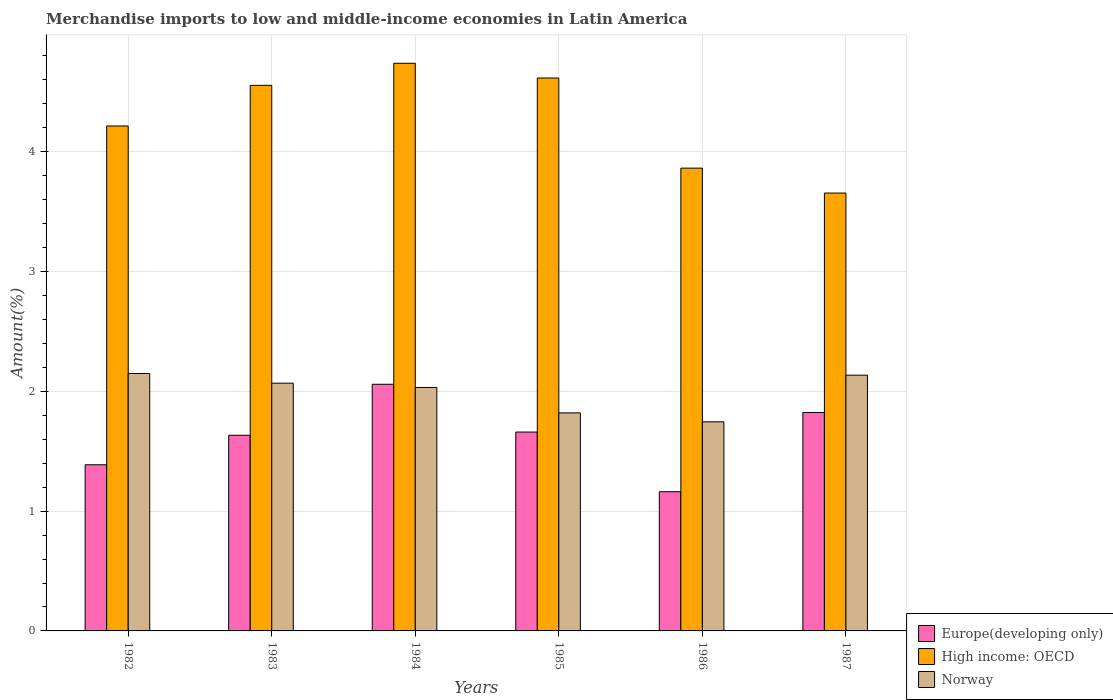How many different coloured bars are there?
Keep it short and to the point. 3. Are the number of bars per tick equal to the number of legend labels?
Offer a terse response. Yes. How many bars are there on the 6th tick from the left?
Give a very brief answer. 3. How many bars are there on the 1st tick from the right?
Your answer should be compact. 3. What is the percentage of amount earned from merchandise imports in High income: OECD in 1984?
Offer a terse response. 4.74. Across all years, what is the maximum percentage of amount earned from merchandise imports in Europe(developing only)?
Offer a terse response. 2.06. Across all years, what is the minimum percentage of amount earned from merchandise imports in High income: OECD?
Give a very brief answer. 3.66. In which year was the percentage of amount earned from merchandise imports in Europe(developing only) maximum?
Ensure brevity in your answer.  1984. In which year was the percentage of amount earned from merchandise imports in Norway minimum?
Provide a short and direct response. 1986. What is the total percentage of amount earned from merchandise imports in High income: OECD in the graph?
Offer a very short reply. 25.64. What is the difference between the percentage of amount earned from merchandise imports in Norway in 1984 and that in 1987?
Ensure brevity in your answer.  -0.1. What is the difference between the percentage of amount earned from merchandise imports in High income: OECD in 1987 and the percentage of amount earned from merchandise imports in Europe(developing only) in 1983?
Offer a very short reply. 2.02. What is the average percentage of amount earned from merchandise imports in Europe(developing only) per year?
Your answer should be very brief. 1.62. In the year 1987, what is the difference between the percentage of amount earned from merchandise imports in Norway and percentage of amount earned from merchandise imports in High income: OECD?
Provide a short and direct response. -1.52. In how many years, is the percentage of amount earned from merchandise imports in Norway greater than 2 %?
Provide a succinct answer. 4. What is the ratio of the percentage of amount earned from merchandise imports in Europe(developing only) in 1983 to that in 1986?
Provide a short and direct response. 1.41. Is the percentage of amount earned from merchandise imports in High income: OECD in 1982 less than that in 1983?
Your response must be concise. Yes. Is the difference between the percentage of amount earned from merchandise imports in Norway in 1982 and 1986 greater than the difference between the percentage of amount earned from merchandise imports in High income: OECD in 1982 and 1986?
Your answer should be compact. Yes. What is the difference between the highest and the second highest percentage of amount earned from merchandise imports in Europe(developing only)?
Provide a short and direct response. 0.24. What is the difference between the highest and the lowest percentage of amount earned from merchandise imports in Europe(developing only)?
Your response must be concise. 0.9. Is the sum of the percentage of amount earned from merchandise imports in Norway in 1982 and 1983 greater than the maximum percentage of amount earned from merchandise imports in Europe(developing only) across all years?
Provide a short and direct response. Yes. What does the 1st bar from the left in 1987 represents?
Your answer should be very brief. Europe(developing only). What does the 3rd bar from the right in 1987 represents?
Give a very brief answer. Europe(developing only). Is it the case that in every year, the sum of the percentage of amount earned from merchandise imports in High income: OECD and percentage of amount earned from merchandise imports in Europe(developing only) is greater than the percentage of amount earned from merchandise imports in Norway?
Your answer should be compact. Yes. How many bars are there?
Your answer should be very brief. 18. How many years are there in the graph?
Your answer should be very brief. 6. What is the difference between two consecutive major ticks on the Y-axis?
Offer a terse response. 1. Does the graph contain grids?
Offer a very short reply. Yes. How many legend labels are there?
Give a very brief answer. 3. How are the legend labels stacked?
Keep it short and to the point. Vertical. What is the title of the graph?
Your response must be concise. Merchandise imports to low and middle-income economies in Latin America. Does "Faeroe Islands" appear as one of the legend labels in the graph?
Your answer should be compact. No. What is the label or title of the X-axis?
Give a very brief answer. Years. What is the label or title of the Y-axis?
Ensure brevity in your answer.  Amount(%). What is the Amount(%) in Europe(developing only) in 1982?
Provide a succinct answer. 1.39. What is the Amount(%) in High income: OECD in 1982?
Offer a terse response. 4.21. What is the Amount(%) in Norway in 1982?
Keep it short and to the point. 2.15. What is the Amount(%) of Europe(developing only) in 1983?
Your answer should be very brief. 1.63. What is the Amount(%) of High income: OECD in 1983?
Your response must be concise. 4.55. What is the Amount(%) of Norway in 1983?
Give a very brief answer. 2.07. What is the Amount(%) in Europe(developing only) in 1984?
Your answer should be very brief. 2.06. What is the Amount(%) in High income: OECD in 1984?
Offer a terse response. 4.74. What is the Amount(%) of Norway in 1984?
Make the answer very short. 2.03. What is the Amount(%) in Europe(developing only) in 1985?
Your response must be concise. 1.66. What is the Amount(%) in High income: OECD in 1985?
Ensure brevity in your answer.  4.62. What is the Amount(%) of Norway in 1985?
Ensure brevity in your answer.  1.82. What is the Amount(%) in Europe(developing only) in 1986?
Ensure brevity in your answer.  1.16. What is the Amount(%) of High income: OECD in 1986?
Give a very brief answer. 3.86. What is the Amount(%) of Norway in 1986?
Provide a short and direct response. 1.75. What is the Amount(%) in Europe(developing only) in 1987?
Keep it short and to the point. 1.82. What is the Amount(%) of High income: OECD in 1987?
Your answer should be very brief. 3.66. What is the Amount(%) in Norway in 1987?
Ensure brevity in your answer.  2.13. Across all years, what is the maximum Amount(%) of Europe(developing only)?
Keep it short and to the point. 2.06. Across all years, what is the maximum Amount(%) in High income: OECD?
Offer a terse response. 4.74. Across all years, what is the maximum Amount(%) in Norway?
Offer a terse response. 2.15. Across all years, what is the minimum Amount(%) in Europe(developing only)?
Provide a succinct answer. 1.16. Across all years, what is the minimum Amount(%) in High income: OECD?
Make the answer very short. 3.66. Across all years, what is the minimum Amount(%) of Norway?
Your answer should be compact. 1.75. What is the total Amount(%) in Europe(developing only) in the graph?
Provide a succinct answer. 9.72. What is the total Amount(%) of High income: OECD in the graph?
Give a very brief answer. 25.64. What is the total Amount(%) of Norway in the graph?
Make the answer very short. 11.95. What is the difference between the Amount(%) of Europe(developing only) in 1982 and that in 1983?
Give a very brief answer. -0.25. What is the difference between the Amount(%) of High income: OECD in 1982 and that in 1983?
Ensure brevity in your answer.  -0.34. What is the difference between the Amount(%) in Norway in 1982 and that in 1983?
Provide a short and direct response. 0.08. What is the difference between the Amount(%) of Europe(developing only) in 1982 and that in 1984?
Give a very brief answer. -0.67. What is the difference between the Amount(%) of High income: OECD in 1982 and that in 1984?
Ensure brevity in your answer.  -0.52. What is the difference between the Amount(%) in Norway in 1982 and that in 1984?
Offer a very short reply. 0.12. What is the difference between the Amount(%) of Europe(developing only) in 1982 and that in 1985?
Keep it short and to the point. -0.27. What is the difference between the Amount(%) of High income: OECD in 1982 and that in 1985?
Keep it short and to the point. -0.4. What is the difference between the Amount(%) of Norway in 1982 and that in 1985?
Offer a very short reply. 0.33. What is the difference between the Amount(%) of Europe(developing only) in 1982 and that in 1986?
Provide a succinct answer. 0.23. What is the difference between the Amount(%) of High income: OECD in 1982 and that in 1986?
Provide a succinct answer. 0.35. What is the difference between the Amount(%) of Norway in 1982 and that in 1986?
Provide a short and direct response. 0.4. What is the difference between the Amount(%) of Europe(developing only) in 1982 and that in 1987?
Offer a terse response. -0.44. What is the difference between the Amount(%) of High income: OECD in 1982 and that in 1987?
Provide a succinct answer. 0.56. What is the difference between the Amount(%) of Norway in 1982 and that in 1987?
Provide a short and direct response. 0.01. What is the difference between the Amount(%) in Europe(developing only) in 1983 and that in 1984?
Give a very brief answer. -0.43. What is the difference between the Amount(%) in High income: OECD in 1983 and that in 1984?
Provide a short and direct response. -0.18. What is the difference between the Amount(%) in Norway in 1983 and that in 1984?
Make the answer very short. 0.04. What is the difference between the Amount(%) in Europe(developing only) in 1983 and that in 1985?
Provide a short and direct response. -0.03. What is the difference between the Amount(%) in High income: OECD in 1983 and that in 1985?
Offer a terse response. -0.06. What is the difference between the Amount(%) in Norway in 1983 and that in 1985?
Your answer should be very brief. 0.25. What is the difference between the Amount(%) of Europe(developing only) in 1983 and that in 1986?
Provide a short and direct response. 0.47. What is the difference between the Amount(%) of High income: OECD in 1983 and that in 1986?
Offer a very short reply. 0.69. What is the difference between the Amount(%) in Norway in 1983 and that in 1986?
Offer a terse response. 0.32. What is the difference between the Amount(%) in Europe(developing only) in 1983 and that in 1987?
Provide a succinct answer. -0.19. What is the difference between the Amount(%) in High income: OECD in 1983 and that in 1987?
Your answer should be compact. 0.9. What is the difference between the Amount(%) of Norway in 1983 and that in 1987?
Ensure brevity in your answer.  -0.07. What is the difference between the Amount(%) of Europe(developing only) in 1984 and that in 1985?
Make the answer very short. 0.4. What is the difference between the Amount(%) of High income: OECD in 1984 and that in 1985?
Offer a very short reply. 0.12. What is the difference between the Amount(%) in Norway in 1984 and that in 1985?
Your answer should be very brief. 0.21. What is the difference between the Amount(%) in Europe(developing only) in 1984 and that in 1986?
Your response must be concise. 0.9. What is the difference between the Amount(%) in High income: OECD in 1984 and that in 1986?
Keep it short and to the point. 0.88. What is the difference between the Amount(%) of Norway in 1984 and that in 1986?
Give a very brief answer. 0.29. What is the difference between the Amount(%) in Europe(developing only) in 1984 and that in 1987?
Your answer should be very brief. 0.24. What is the difference between the Amount(%) of High income: OECD in 1984 and that in 1987?
Make the answer very short. 1.08. What is the difference between the Amount(%) of Norway in 1984 and that in 1987?
Your answer should be compact. -0.1. What is the difference between the Amount(%) of Europe(developing only) in 1985 and that in 1986?
Your answer should be compact. 0.5. What is the difference between the Amount(%) of High income: OECD in 1985 and that in 1986?
Your answer should be compact. 0.75. What is the difference between the Amount(%) in Norway in 1985 and that in 1986?
Your response must be concise. 0.07. What is the difference between the Amount(%) in Europe(developing only) in 1985 and that in 1987?
Offer a terse response. -0.16. What is the difference between the Amount(%) in High income: OECD in 1985 and that in 1987?
Provide a succinct answer. 0.96. What is the difference between the Amount(%) of Norway in 1985 and that in 1987?
Ensure brevity in your answer.  -0.31. What is the difference between the Amount(%) of Europe(developing only) in 1986 and that in 1987?
Give a very brief answer. -0.66. What is the difference between the Amount(%) of High income: OECD in 1986 and that in 1987?
Make the answer very short. 0.21. What is the difference between the Amount(%) in Norway in 1986 and that in 1987?
Your answer should be compact. -0.39. What is the difference between the Amount(%) in Europe(developing only) in 1982 and the Amount(%) in High income: OECD in 1983?
Keep it short and to the point. -3.17. What is the difference between the Amount(%) of Europe(developing only) in 1982 and the Amount(%) of Norway in 1983?
Provide a succinct answer. -0.68. What is the difference between the Amount(%) in High income: OECD in 1982 and the Amount(%) in Norway in 1983?
Ensure brevity in your answer.  2.15. What is the difference between the Amount(%) in Europe(developing only) in 1982 and the Amount(%) in High income: OECD in 1984?
Ensure brevity in your answer.  -3.35. What is the difference between the Amount(%) of Europe(developing only) in 1982 and the Amount(%) of Norway in 1984?
Your answer should be very brief. -0.65. What is the difference between the Amount(%) of High income: OECD in 1982 and the Amount(%) of Norway in 1984?
Your response must be concise. 2.18. What is the difference between the Amount(%) of Europe(developing only) in 1982 and the Amount(%) of High income: OECD in 1985?
Provide a short and direct response. -3.23. What is the difference between the Amount(%) in Europe(developing only) in 1982 and the Amount(%) in Norway in 1985?
Your response must be concise. -0.43. What is the difference between the Amount(%) in High income: OECD in 1982 and the Amount(%) in Norway in 1985?
Give a very brief answer. 2.4. What is the difference between the Amount(%) in Europe(developing only) in 1982 and the Amount(%) in High income: OECD in 1986?
Your answer should be compact. -2.48. What is the difference between the Amount(%) in Europe(developing only) in 1982 and the Amount(%) in Norway in 1986?
Your response must be concise. -0.36. What is the difference between the Amount(%) in High income: OECD in 1982 and the Amount(%) in Norway in 1986?
Your response must be concise. 2.47. What is the difference between the Amount(%) of Europe(developing only) in 1982 and the Amount(%) of High income: OECD in 1987?
Give a very brief answer. -2.27. What is the difference between the Amount(%) of Europe(developing only) in 1982 and the Amount(%) of Norway in 1987?
Your answer should be compact. -0.75. What is the difference between the Amount(%) in High income: OECD in 1982 and the Amount(%) in Norway in 1987?
Keep it short and to the point. 2.08. What is the difference between the Amount(%) in Europe(developing only) in 1983 and the Amount(%) in High income: OECD in 1984?
Give a very brief answer. -3.1. What is the difference between the Amount(%) of Europe(developing only) in 1983 and the Amount(%) of Norway in 1984?
Your response must be concise. -0.4. What is the difference between the Amount(%) of High income: OECD in 1983 and the Amount(%) of Norway in 1984?
Your answer should be compact. 2.52. What is the difference between the Amount(%) in Europe(developing only) in 1983 and the Amount(%) in High income: OECD in 1985?
Provide a succinct answer. -2.98. What is the difference between the Amount(%) in Europe(developing only) in 1983 and the Amount(%) in Norway in 1985?
Keep it short and to the point. -0.19. What is the difference between the Amount(%) in High income: OECD in 1983 and the Amount(%) in Norway in 1985?
Provide a succinct answer. 2.73. What is the difference between the Amount(%) of Europe(developing only) in 1983 and the Amount(%) of High income: OECD in 1986?
Ensure brevity in your answer.  -2.23. What is the difference between the Amount(%) of Europe(developing only) in 1983 and the Amount(%) of Norway in 1986?
Offer a terse response. -0.11. What is the difference between the Amount(%) in High income: OECD in 1983 and the Amount(%) in Norway in 1986?
Your answer should be compact. 2.81. What is the difference between the Amount(%) in Europe(developing only) in 1983 and the Amount(%) in High income: OECD in 1987?
Offer a terse response. -2.02. What is the difference between the Amount(%) in Europe(developing only) in 1983 and the Amount(%) in Norway in 1987?
Your answer should be very brief. -0.5. What is the difference between the Amount(%) in High income: OECD in 1983 and the Amount(%) in Norway in 1987?
Your answer should be compact. 2.42. What is the difference between the Amount(%) of Europe(developing only) in 1984 and the Amount(%) of High income: OECD in 1985?
Make the answer very short. -2.56. What is the difference between the Amount(%) in Europe(developing only) in 1984 and the Amount(%) in Norway in 1985?
Ensure brevity in your answer.  0.24. What is the difference between the Amount(%) in High income: OECD in 1984 and the Amount(%) in Norway in 1985?
Offer a terse response. 2.92. What is the difference between the Amount(%) of Europe(developing only) in 1984 and the Amount(%) of High income: OECD in 1986?
Give a very brief answer. -1.8. What is the difference between the Amount(%) of Europe(developing only) in 1984 and the Amount(%) of Norway in 1986?
Offer a terse response. 0.31. What is the difference between the Amount(%) of High income: OECD in 1984 and the Amount(%) of Norway in 1986?
Provide a succinct answer. 2.99. What is the difference between the Amount(%) in Europe(developing only) in 1984 and the Amount(%) in High income: OECD in 1987?
Offer a terse response. -1.6. What is the difference between the Amount(%) in Europe(developing only) in 1984 and the Amount(%) in Norway in 1987?
Your answer should be compact. -0.08. What is the difference between the Amount(%) in High income: OECD in 1984 and the Amount(%) in Norway in 1987?
Provide a succinct answer. 2.6. What is the difference between the Amount(%) of Europe(developing only) in 1985 and the Amount(%) of High income: OECD in 1986?
Give a very brief answer. -2.2. What is the difference between the Amount(%) of Europe(developing only) in 1985 and the Amount(%) of Norway in 1986?
Make the answer very short. -0.09. What is the difference between the Amount(%) of High income: OECD in 1985 and the Amount(%) of Norway in 1986?
Offer a very short reply. 2.87. What is the difference between the Amount(%) in Europe(developing only) in 1985 and the Amount(%) in High income: OECD in 1987?
Give a very brief answer. -2. What is the difference between the Amount(%) in Europe(developing only) in 1985 and the Amount(%) in Norway in 1987?
Offer a very short reply. -0.47. What is the difference between the Amount(%) of High income: OECD in 1985 and the Amount(%) of Norway in 1987?
Make the answer very short. 2.48. What is the difference between the Amount(%) in Europe(developing only) in 1986 and the Amount(%) in High income: OECD in 1987?
Ensure brevity in your answer.  -2.49. What is the difference between the Amount(%) in Europe(developing only) in 1986 and the Amount(%) in Norway in 1987?
Your response must be concise. -0.97. What is the difference between the Amount(%) of High income: OECD in 1986 and the Amount(%) of Norway in 1987?
Make the answer very short. 1.73. What is the average Amount(%) in Europe(developing only) per year?
Keep it short and to the point. 1.62. What is the average Amount(%) in High income: OECD per year?
Your response must be concise. 4.27. What is the average Amount(%) in Norway per year?
Your answer should be compact. 1.99. In the year 1982, what is the difference between the Amount(%) in Europe(developing only) and Amount(%) in High income: OECD?
Provide a succinct answer. -2.83. In the year 1982, what is the difference between the Amount(%) in Europe(developing only) and Amount(%) in Norway?
Your response must be concise. -0.76. In the year 1982, what is the difference between the Amount(%) of High income: OECD and Amount(%) of Norway?
Provide a short and direct response. 2.07. In the year 1983, what is the difference between the Amount(%) in Europe(developing only) and Amount(%) in High income: OECD?
Make the answer very short. -2.92. In the year 1983, what is the difference between the Amount(%) in Europe(developing only) and Amount(%) in Norway?
Offer a terse response. -0.43. In the year 1983, what is the difference between the Amount(%) of High income: OECD and Amount(%) of Norway?
Your answer should be very brief. 2.49. In the year 1984, what is the difference between the Amount(%) in Europe(developing only) and Amount(%) in High income: OECD?
Your response must be concise. -2.68. In the year 1984, what is the difference between the Amount(%) of Europe(developing only) and Amount(%) of Norway?
Give a very brief answer. 0.03. In the year 1984, what is the difference between the Amount(%) in High income: OECD and Amount(%) in Norway?
Your response must be concise. 2.71. In the year 1985, what is the difference between the Amount(%) of Europe(developing only) and Amount(%) of High income: OECD?
Make the answer very short. -2.96. In the year 1985, what is the difference between the Amount(%) in Europe(developing only) and Amount(%) in Norway?
Your response must be concise. -0.16. In the year 1985, what is the difference between the Amount(%) of High income: OECD and Amount(%) of Norway?
Your response must be concise. 2.8. In the year 1986, what is the difference between the Amount(%) of Europe(developing only) and Amount(%) of High income: OECD?
Your answer should be very brief. -2.7. In the year 1986, what is the difference between the Amount(%) of Europe(developing only) and Amount(%) of Norway?
Your response must be concise. -0.58. In the year 1986, what is the difference between the Amount(%) of High income: OECD and Amount(%) of Norway?
Offer a terse response. 2.12. In the year 1987, what is the difference between the Amount(%) of Europe(developing only) and Amount(%) of High income: OECD?
Provide a short and direct response. -1.83. In the year 1987, what is the difference between the Amount(%) of Europe(developing only) and Amount(%) of Norway?
Offer a terse response. -0.31. In the year 1987, what is the difference between the Amount(%) in High income: OECD and Amount(%) in Norway?
Your answer should be very brief. 1.52. What is the ratio of the Amount(%) in Europe(developing only) in 1982 to that in 1983?
Your response must be concise. 0.85. What is the ratio of the Amount(%) in High income: OECD in 1982 to that in 1983?
Your answer should be compact. 0.93. What is the ratio of the Amount(%) in Norway in 1982 to that in 1983?
Offer a very short reply. 1.04. What is the ratio of the Amount(%) in Europe(developing only) in 1982 to that in 1984?
Ensure brevity in your answer.  0.67. What is the ratio of the Amount(%) of High income: OECD in 1982 to that in 1984?
Ensure brevity in your answer.  0.89. What is the ratio of the Amount(%) in Norway in 1982 to that in 1984?
Provide a succinct answer. 1.06. What is the ratio of the Amount(%) in Europe(developing only) in 1982 to that in 1985?
Offer a very short reply. 0.84. What is the ratio of the Amount(%) in High income: OECD in 1982 to that in 1985?
Your answer should be very brief. 0.91. What is the ratio of the Amount(%) of Norway in 1982 to that in 1985?
Offer a terse response. 1.18. What is the ratio of the Amount(%) of Europe(developing only) in 1982 to that in 1986?
Your answer should be compact. 1.19. What is the ratio of the Amount(%) in High income: OECD in 1982 to that in 1986?
Offer a very short reply. 1.09. What is the ratio of the Amount(%) of Norway in 1982 to that in 1986?
Offer a terse response. 1.23. What is the ratio of the Amount(%) in Europe(developing only) in 1982 to that in 1987?
Your response must be concise. 0.76. What is the ratio of the Amount(%) in High income: OECD in 1982 to that in 1987?
Keep it short and to the point. 1.15. What is the ratio of the Amount(%) of Norway in 1982 to that in 1987?
Your answer should be compact. 1.01. What is the ratio of the Amount(%) of Europe(developing only) in 1983 to that in 1984?
Your answer should be very brief. 0.79. What is the ratio of the Amount(%) of High income: OECD in 1983 to that in 1984?
Offer a terse response. 0.96. What is the ratio of the Amount(%) of Norway in 1983 to that in 1984?
Ensure brevity in your answer.  1.02. What is the ratio of the Amount(%) in Europe(developing only) in 1983 to that in 1985?
Provide a short and direct response. 0.98. What is the ratio of the Amount(%) of High income: OECD in 1983 to that in 1985?
Your response must be concise. 0.99. What is the ratio of the Amount(%) in Norway in 1983 to that in 1985?
Offer a terse response. 1.14. What is the ratio of the Amount(%) of Europe(developing only) in 1983 to that in 1986?
Your answer should be very brief. 1.41. What is the ratio of the Amount(%) of High income: OECD in 1983 to that in 1986?
Your response must be concise. 1.18. What is the ratio of the Amount(%) in Norway in 1983 to that in 1986?
Provide a succinct answer. 1.18. What is the ratio of the Amount(%) in Europe(developing only) in 1983 to that in 1987?
Your answer should be compact. 0.9. What is the ratio of the Amount(%) in High income: OECD in 1983 to that in 1987?
Make the answer very short. 1.25. What is the ratio of the Amount(%) of Norway in 1983 to that in 1987?
Provide a succinct answer. 0.97. What is the ratio of the Amount(%) in Europe(developing only) in 1984 to that in 1985?
Your answer should be very brief. 1.24. What is the ratio of the Amount(%) of High income: OECD in 1984 to that in 1985?
Offer a terse response. 1.03. What is the ratio of the Amount(%) of Norway in 1984 to that in 1985?
Your answer should be very brief. 1.12. What is the ratio of the Amount(%) of Europe(developing only) in 1984 to that in 1986?
Ensure brevity in your answer.  1.77. What is the ratio of the Amount(%) of High income: OECD in 1984 to that in 1986?
Offer a terse response. 1.23. What is the ratio of the Amount(%) of Norway in 1984 to that in 1986?
Keep it short and to the point. 1.16. What is the ratio of the Amount(%) of Europe(developing only) in 1984 to that in 1987?
Offer a very short reply. 1.13. What is the ratio of the Amount(%) in High income: OECD in 1984 to that in 1987?
Your answer should be compact. 1.3. What is the ratio of the Amount(%) of Norway in 1984 to that in 1987?
Offer a terse response. 0.95. What is the ratio of the Amount(%) in Europe(developing only) in 1985 to that in 1986?
Give a very brief answer. 1.43. What is the ratio of the Amount(%) in High income: OECD in 1985 to that in 1986?
Give a very brief answer. 1.19. What is the ratio of the Amount(%) of Norway in 1985 to that in 1986?
Provide a succinct answer. 1.04. What is the ratio of the Amount(%) in Europe(developing only) in 1985 to that in 1987?
Ensure brevity in your answer.  0.91. What is the ratio of the Amount(%) of High income: OECD in 1985 to that in 1987?
Your response must be concise. 1.26. What is the ratio of the Amount(%) of Norway in 1985 to that in 1987?
Your response must be concise. 0.85. What is the ratio of the Amount(%) of Europe(developing only) in 1986 to that in 1987?
Your answer should be compact. 0.64. What is the ratio of the Amount(%) of High income: OECD in 1986 to that in 1987?
Keep it short and to the point. 1.06. What is the ratio of the Amount(%) of Norway in 1986 to that in 1987?
Offer a terse response. 0.82. What is the difference between the highest and the second highest Amount(%) in Europe(developing only)?
Offer a terse response. 0.24. What is the difference between the highest and the second highest Amount(%) of High income: OECD?
Offer a terse response. 0.12. What is the difference between the highest and the second highest Amount(%) of Norway?
Offer a terse response. 0.01. What is the difference between the highest and the lowest Amount(%) of Europe(developing only)?
Your answer should be compact. 0.9. What is the difference between the highest and the lowest Amount(%) in High income: OECD?
Provide a succinct answer. 1.08. What is the difference between the highest and the lowest Amount(%) of Norway?
Make the answer very short. 0.4. 